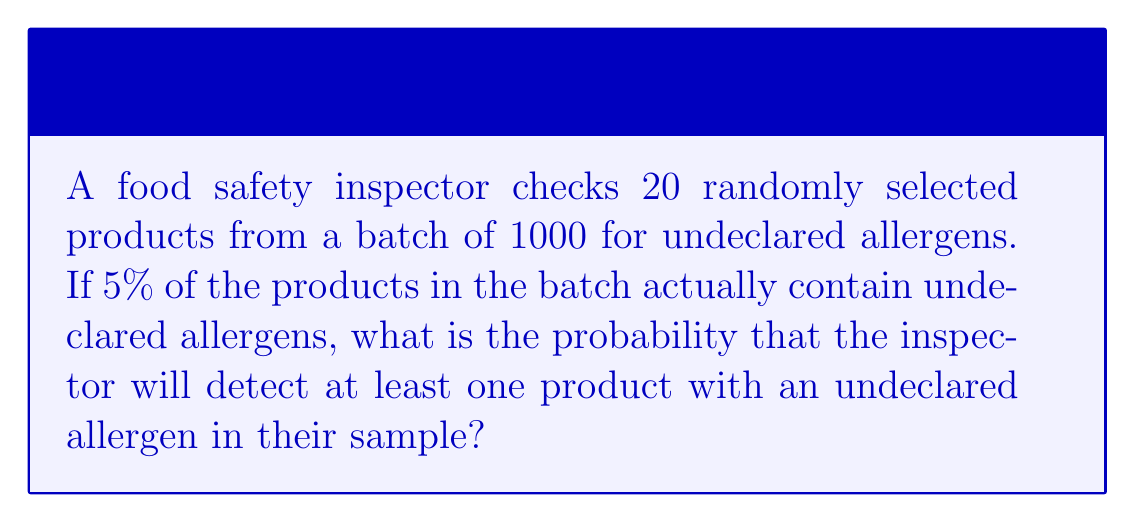Help me with this question. Let's approach this step-by-step:

1) First, we need to calculate the probability of not detecting any products with undeclared allergens.

2) The probability of a single product not having an undeclared allergen is 95% or 0.95.

3) For all 20 sampled products to not have undeclared allergens, each one must not have them. This is calculated by multiplying the individual probabilities:

   $$(0.95)^{20}$$

4) This gives us the probability of not detecting any products with undeclared allergens. To find the probability of detecting at least one, we subtract this from 1:

   $$1 - (0.95)^{20}$$

5) Let's calculate this:
   $$(0.95)^{20} \approx 0.3585$$
   $$1 - 0.3585 = 0.6415$$

6) Therefore, the probability of detecting at least one product with an undeclared allergen is approximately 0.6415 or 64.15%.
Answer: $1 - (0.95)^{20} \approx 0.6415$ 